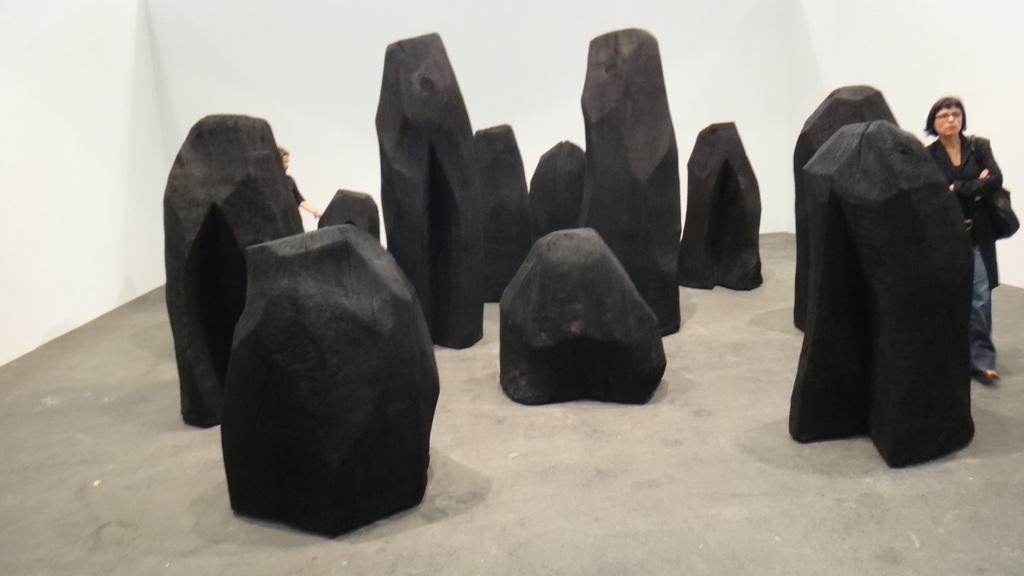Describe this image in one or two sentences. In this picture there are black stones in the center. On the right side there is a woman walking. In the background there is a wall which is white in colour and on the left side there is a person behind the stone. 